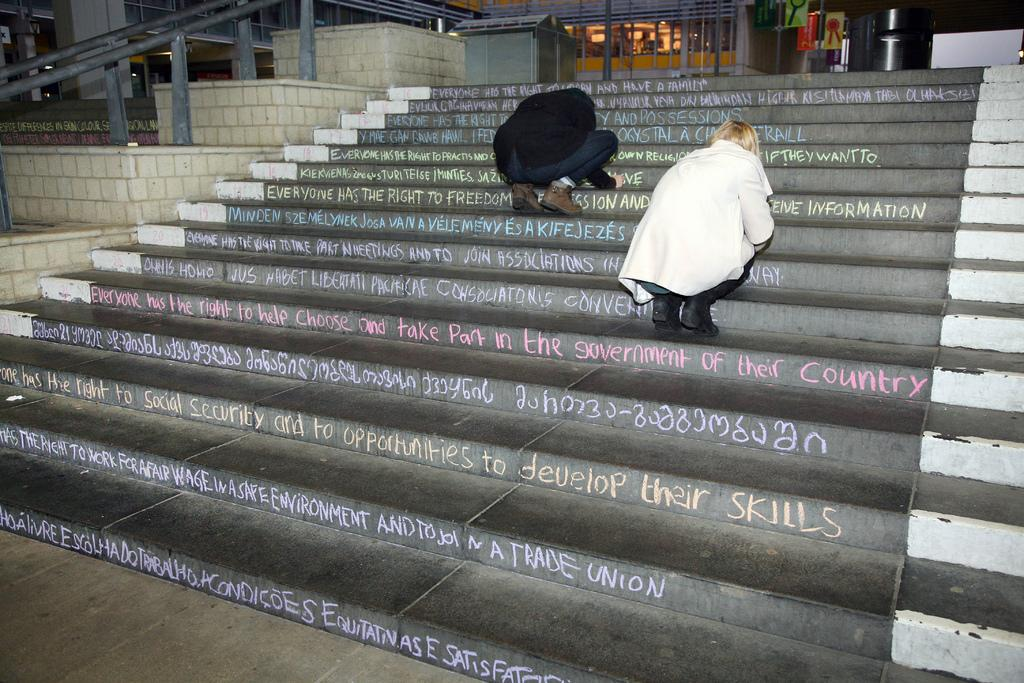What are the people in the image doing? The people in the image are on the stairs in the foreground. What can be seen in the top left side of the image? There are railings in the top left side of the image. What is visible in the top side of the image? There are windows and posters in the top side of the image. What type of nail can be seen in the image? There is no nail present in the image. How is the lock used in the image? There is no lock present in the image. 